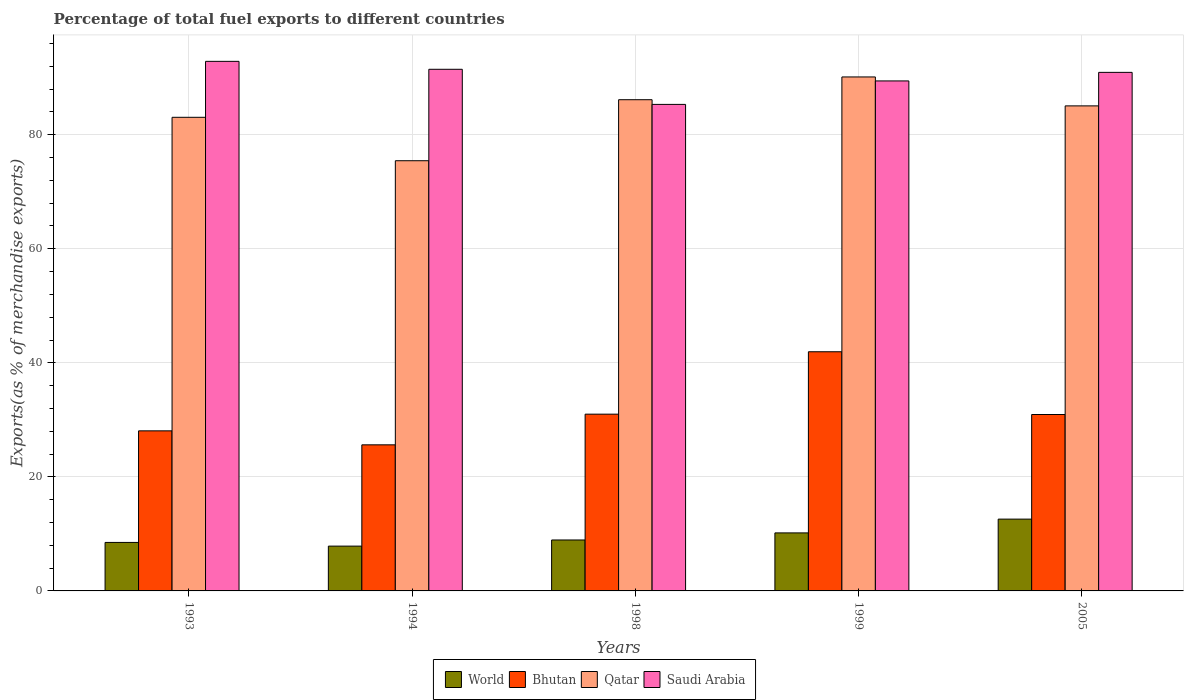How many different coloured bars are there?
Provide a succinct answer. 4. Are the number of bars per tick equal to the number of legend labels?
Give a very brief answer. Yes. Are the number of bars on each tick of the X-axis equal?
Your response must be concise. Yes. How many bars are there on the 3rd tick from the right?
Your answer should be very brief. 4. In how many cases, is the number of bars for a given year not equal to the number of legend labels?
Provide a short and direct response. 0. What is the percentage of exports to different countries in Bhutan in 1994?
Offer a terse response. 25.62. Across all years, what is the maximum percentage of exports to different countries in Bhutan?
Give a very brief answer. 41.94. Across all years, what is the minimum percentage of exports to different countries in World?
Provide a short and direct response. 7.86. What is the total percentage of exports to different countries in World in the graph?
Make the answer very short. 48.06. What is the difference between the percentage of exports to different countries in Qatar in 1994 and that in 1999?
Give a very brief answer. -14.69. What is the difference between the percentage of exports to different countries in World in 1993 and the percentage of exports to different countries in Saudi Arabia in 2005?
Your response must be concise. -82.43. What is the average percentage of exports to different countries in Bhutan per year?
Your answer should be very brief. 31.51. In the year 1998, what is the difference between the percentage of exports to different countries in Saudi Arabia and percentage of exports to different countries in World?
Give a very brief answer. 76.38. What is the ratio of the percentage of exports to different countries in World in 1993 to that in 2005?
Provide a short and direct response. 0.68. What is the difference between the highest and the second highest percentage of exports to different countries in World?
Keep it short and to the point. 2.42. What is the difference between the highest and the lowest percentage of exports to different countries in Saudi Arabia?
Offer a terse response. 7.55. In how many years, is the percentage of exports to different countries in Qatar greater than the average percentage of exports to different countries in Qatar taken over all years?
Ensure brevity in your answer.  3. Is the sum of the percentage of exports to different countries in Qatar in 1993 and 2005 greater than the maximum percentage of exports to different countries in Bhutan across all years?
Your answer should be very brief. Yes. Is it the case that in every year, the sum of the percentage of exports to different countries in Saudi Arabia and percentage of exports to different countries in Bhutan is greater than the sum of percentage of exports to different countries in World and percentage of exports to different countries in Qatar?
Offer a very short reply. Yes. What does the 1st bar from the left in 1999 represents?
Keep it short and to the point. World. What does the 3rd bar from the right in 1999 represents?
Your answer should be compact. Bhutan. What is the difference between two consecutive major ticks on the Y-axis?
Offer a very short reply. 20. Does the graph contain any zero values?
Your answer should be compact. No. Does the graph contain grids?
Your answer should be very brief. Yes. How many legend labels are there?
Your answer should be compact. 4. How are the legend labels stacked?
Provide a short and direct response. Horizontal. What is the title of the graph?
Make the answer very short. Percentage of total fuel exports to different countries. Does "Upper middle income" appear as one of the legend labels in the graph?
Provide a succinct answer. No. What is the label or title of the Y-axis?
Give a very brief answer. Exports(as % of merchandise exports). What is the Exports(as % of merchandise exports) in World in 1993?
Provide a succinct answer. 8.5. What is the Exports(as % of merchandise exports) in Bhutan in 1993?
Provide a short and direct response. 28.07. What is the Exports(as % of merchandise exports) in Qatar in 1993?
Your answer should be very brief. 83.06. What is the Exports(as % of merchandise exports) in Saudi Arabia in 1993?
Offer a terse response. 92.87. What is the Exports(as % of merchandise exports) in World in 1994?
Offer a terse response. 7.86. What is the Exports(as % of merchandise exports) of Bhutan in 1994?
Your answer should be very brief. 25.62. What is the Exports(as % of merchandise exports) of Qatar in 1994?
Your response must be concise. 75.44. What is the Exports(as % of merchandise exports) in Saudi Arabia in 1994?
Your response must be concise. 91.48. What is the Exports(as % of merchandise exports) of World in 1998?
Provide a succinct answer. 8.93. What is the Exports(as % of merchandise exports) in Bhutan in 1998?
Your answer should be very brief. 31. What is the Exports(as % of merchandise exports) in Qatar in 1998?
Provide a succinct answer. 86.14. What is the Exports(as % of merchandise exports) in Saudi Arabia in 1998?
Provide a short and direct response. 85.32. What is the Exports(as % of merchandise exports) of World in 1999?
Your response must be concise. 10.18. What is the Exports(as % of merchandise exports) in Bhutan in 1999?
Give a very brief answer. 41.94. What is the Exports(as % of merchandise exports) of Qatar in 1999?
Make the answer very short. 90.13. What is the Exports(as % of merchandise exports) in Saudi Arabia in 1999?
Provide a short and direct response. 89.44. What is the Exports(as % of merchandise exports) of World in 2005?
Your answer should be very brief. 12.59. What is the Exports(as % of merchandise exports) of Bhutan in 2005?
Make the answer very short. 30.94. What is the Exports(as % of merchandise exports) of Qatar in 2005?
Keep it short and to the point. 85.06. What is the Exports(as % of merchandise exports) of Saudi Arabia in 2005?
Ensure brevity in your answer.  90.94. Across all years, what is the maximum Exports(as % of merchandise exports) in World?
Ensure brevity in your answer.  12.59. Across all years, what is the maximum Exports(as % of merchandise exports) in Bhutan?
Your answer should be very brief. 41.94. Across all years, what is the maximum Exports(as % of merchandise exports) in Qatar?
Offer a very short reply. 90.13. Across all years, what is the maximum Exports(as % of merchandise exports) of Saudi Arabia?
Your answer should be very brief. 92.87. Across all years, what is the minimum Exports(as % of merchandise exports) of World?
Your answer should be very brief. 7.86. Across all years, what is the minimum Exports(as % of merchandise exports) in Bhutan?
Your response must be concise. 25.62. Across all years, what is the minimum Exports(as % of merchandise exports) of Qatar?
Offer a very short reply. 75.44. Across all years, what is the minimum Exports(as % of merchandise exports) of Saudi Arabia?
Provide a succinct answer. 85.32. What is the total Exports(as % of merchandise exports) in World in the graph?
Make the answer very short. 48.06. What is the total Exports(as % of merchandise exports) of Bhutan in the graph?
Your answer should be compact. 157.57. What is the total Exports(as % of merchandise exports) in Qatar in the graph?
Give a very brief answer. 419.83. What is the total Exports(as % of merchandise exports) of Saudi Arabia in the graph?
Provide a short and direct response. 450.03. What is the difference between the Exports(as % of merchandise exports) in World in 1993 and that in 1994?
Provide a succinct answer. 0.65. What is the difference between the Exports(as % of merchandise exports) of Bhutan in 1993 and that in 1994?
Your answer should be compact. 2.45. What is the difference between the Exports(as % of merchandise exports) of Qatar in 1993 and that in 1994?
Your response must be concise. 7.62. What is the difference between the Exports(as % of merchandise exports) in Saudi Arabia in 1993 and that in 1994?
Provide a short and direct response. 1.39. What is the difference between the Exports(as % of merchandise exports) of World in 1993 and that in 1998?
Ensure brevity in your answer.  -0.43. What is the difference between the Exports(as % of merchandise exports) in Bhutan in 1993 and that in 1998?
Provide a short and direct response. -2.93. What is the difference between the Exports(as % of merchandise exports) of Qatar in 1993 and that in 1998?
Your answer should be very brief. -3.09. What is the difference between the Exports(as % of merchandise exports) in Saudi Arabia in 1993 and that in 1998?
Keep it short and to the point. 7.55. What is the difference between the Exports(as % of merchandise exports) in World in 1993 and that in 1999?
Your answer should be very brief. -1.67. What is the difference between the Exports(as % of merchandise exports) in Bhutan in 1993 and that in 1999?
Your answer should be compact. -13.87. What is the difference between the Exports(as % of merchandise exports) of Qatar in 1993 and that in 1999?
Keep it short and to the point. -7.08. What is the difference between the Exports(as % of merchandise exports) of Saudi Arabia in 1993 and that in 1999?
Keep it short and to the point. 3.43. What is the difference between the Exports(as % of merchandise exports) in World in 1993 and that in 2005?
Offer a very short reply. -4.09. What is the difference between the Exports(as % of merchandise exports) of Bhutan in 1993 and that in 2005?
Your response must be concise. -2.87. What is the difference between the Exports(as % of merchandise exports) in Qatar in 1993 and that in 2005?
Offer a very short reply. -2. What is the difference between the Exports(as % of merchandise exports) of Saudi Arabia in 1993 and that in 2005?
Keep it short and to the point. 1.93. What is the difference between the Exports(as % of merchandise exports) of World in 1994 and that in 1998?
Offer a terse response. -1.08. What is the difference between the Exports(as % of merchandise exports) in Bhutan in 1994 and that in 1998?
Your response must be concise. -5.38. What is the difference between the Exports(as % of merchandise exports) in Qatar in 1994 and that in 1998?
Your response must be concise. -10.7. What is the difference between the Exports(as % of merchandise exports) in Saudi Arabia in 1994 and that in 1998?
Ensure brevity in your answer.  6.16. What is the difference between the Exports(as % of merchandise exports) in World in 1994 and that in 1999?
Your answer should be very brief. -2.32. What is the difference between the Exports(as % of merchandise exports) of Bhutan in 1994 and that in 1999?
Provide a short and direct response. -16.32. What is the difference between the Exports(as % of merchandise exports) of Qatar in 1994 and that in 1999?
Offer a terse response. -14.69. What is the difference between the Exports(as % of merchandise exports) in Saudi Arabia in 1994 and that in 1999?
Provide a succinct answer. 2.04. What is the difference between the Exports(as % of merchandise exports) in World in 1994 and that in 2005?
Make the answer very short. -4.74. What is the difference between the Exports(as % of merchandise exports) of Bhutan in 1994 and that in 2005?
Make the answer very short. -5.32. What is the difference between the Exports(as % of merchandise exports) in Qatar in 1994 and that in 2005?
Your answer should be compact. -9.62. What is the difference between the Exports(as % of merchandise exports) in Saudi Arabia in 1994 and that in 2005?
Your answer should be very brief. 0.54. What is the difference between the Exports(as % of merchandise exports) in World in 1998 and that in 1999?
Keep it short and to the point. -1.24. What is the difference between the Exports(as % of merchandise exports) in Bhutan in 1998 and that in 1999?
Your answer should be very brief. -10.94. What is the difference between the Exports(as % of merchandise exports) of Qatar in 1998 and that in 1999?
Make the answer very short. -3.99. What is the difference between the Exports(as % of merchandise exports) in Saudi Arabia in 1998 and that in 1999?
Offer a very short reply. -4.12. What is the difference between the Exports(as % of merchandise exports) of World in 1998 and that in 2005?
Your response must be concise. -3.66. What is the difference between the Exports(as % of merchandise exports) of Bhutan in 1998 and that in 2005?
Ensure brevity in your answer.  0.06. What is the difference between the Exports(as % of merchandise exports) in Qatar in 1998 and that in 2005?
Provide a succinct answer. 1.08. What is the difference between the Exports(as % of merchandise exports) in Saudi Arabia in 1998 and that in 2005?
Your response must be concise. -5.62. What is the difference between the Exports(as % of merchandise exports) in World in 1999 and that in 2005?
Provide a succinct answer. -2.42. What is the difference between the Exports(as % of merchandise exports) of Bhutan in 1999 and that in 2005?
Offer a very short reply. 11. What is the difference between the Exports(as % of merchandise exports) in Qatar in 1999 and that in 2005?
Ensure brevity in your answer.  5.07. What is the difference between the Exports(as % of merchandise exports) in Saudi Arabia in 1999 and that in 2005?
Keep it short and to the point. -1.5. What is the difference between the Exports(as % of merchandise exports) in World in 1993 and the Exports(as % of merchandise exports) in Bhutan in 1994?
Give a very brief answer. -17.12. What is the difference between the Exports(as % of merchandise exports) in World in 1993 and the Exports(as % of merchandise exports) in Qatar in 1994?
Make the answer very short. -66.94. What is the difference between the Exports(as % of merchandise exports) in World in 1993 and the Exports(as % of merchandise exports) in Saudi Arabia in 1994?
Keep it short and to the point. -82.97. What is the difference between the Exports(as % of merchandise exports) of Bhutan in 1993 and the Exports(as % of merchandise exports) of Qatar in 1994?
Your answer should be very brief. -47.37. What is the difference between the Exports(as % of merchandise exports) in Bhutan in 1993 and the Exports(as % of merchandise exports) in Saudi Arabia in 1994?
Your response must be concise. -63.41. What is the difference between the Exports(as % of merchandise exports) of Qatar in 1993 and the Exports(as % of merchandise exports) of Saudi Arabia in 1994?
Provide a short and direct response. -8.42. What is the difference between the Exports(as % of merchandise exports) of World in 1993 and the Exports(as % of merchandise exports) of Bhutan in 1998?
Offer a very short reply. -22.5. What is the difference between the Exports(as % of merchandise exports) in World in 1993 and the Exports(as % of merchandise exports) in Qatar in 1998?
Your response must be concise. -77.64. What is the difference between the Exports(as % of merchandise exports) of World in 1993 and the Exports(as % of merchandise exports) of Saudi Arabia in 1998?
Your response must be concise. -76.82. What is the difference between the Exports(as % of merchandise exports) of Bhutan in 1993 and the Exports(as % of merchandise exports) of Qatar in 1998?
Offer a very short reply. -58.07. What is the difference between the Exports(as % of merchandise exports) of Bhutan in 1993 and the Exports(as % of merchandise exports) of Saudi Arabia in 1998?
Provide a succinct answer. -57.25. What is the difference between the Exports(as % of merchandise exports) of Qatar in 1993 and the Exports(as % of merchandise exports) of Saudi Arabia in 1998?
Provide a succinct answer. -2.26. What is the difference between the Exports(as % of merchandise exports) of World in 1993 and the Exports(as % of merchandise exports) of Bhutan in 1999?
Your answer should be compact. -33.44. What is the difference between the Exports(as % of merchandise exports) of World in 1993 and the Exports(as % of merchandise exports) of Qatar in 1999?
Your response must be concise. -81.63. What is the difference between the Exports(as % of merchandise exports) of World in 1993 and the Exports(as % of merchandise exports) of Saudi Arabia in 1999?
Your answer should be very brief. -80.93. What is the difference between the Exports(as % of merchandise exports) in Bhutan in 1993 and the Exports(as % of merchandise exports) in Qatar in 1999?
Offer a very short reply. -62.06. What is the difference between the Exports(as % of merchandise exports) in Bhutan in 1993 and the Exports(as % of merchandise exports) in Saudi Arabia in 1999?
Your answer should be very brief. -61.36. What is the difference between the Exports(as % of merchandise exports) of Qatar in 1993 and the Exports(as % of merchandise exports) of Saudi Arabia in 1999?
Ensure brevity in your answer.  -6.38. What is the difference between the Exports(as % of merchandise exports) in World in 1993 and the Exports(as % of merchandise exports) in Bhutan in 2005?
Your answer should be very brief. -22.43. What is the difference between the Exports(as % of merchandise exports) in World in 1993 and the Exports(as % of merchandise exports) in Qatar in 2005?
Keep it short and to the point. -76.56. What is the difference between the Exports(as % of merchandise exports) in World in 1993 and the Exports(as % of merchandise exports) in Saudi Arabia in 2005?
Ensure brevity in your answer.  -82.43. What is the difference between the Exports(as % of merchandise exports) of Bhutan in 1993 and the Exports(as % of merchandise exports) of Qatar in 2005?
Make the answer very short. -56.99. What is the difference between the Exports(as % of merchandise exports) of Bhutan in 1993 and the Exports(as % of merchandise exports) of Saudi Arabia in 2005?
Your answer should be compact. -62.86. What is the difference between the Exports(as % of merchandise exports) in Qatar in 1993 and the Exports(as % of merchandise exports) in Saudi Arabia in 2005?
Your answer should be compact. -7.88. What is the difference between the Exports(as % of merchandise exports) in World in 1994 and the Exports(as % of merchandise exports) in Bhutan in 1998?
Offer a very short reply. -23.14. What is the difference between the Exports(as % of merchandise exports) of World in 1994 and the Exports(as % of merchandise exports) of Qatar in 1998?
Make the answer very short. -78.28. What is the difference between the Exports(as % of merchandise exports) in World in 1994 and the Exports(as % of merchandise exports) in Saudi Arabia in 1998?
Your response must be concise. -77.46. What is the difference between the Exports(as % of merchandise exports) of Bhutan in 1994 and the Exports(as % of merchandise exports) of Qatar in 1998?
Offer a very short reply. -60.52. What is the difference between the Exports(as % of merchandise exports) in Bhutan in 1994 and the Exports(as % of merchandise exports) in Saudi Arabia in 1998?
Give a very brief answer. -59.7. What is the difference between the Exports(as % of merchandise exports) in Qatar in 1994 and the Exports(as % of merchandise exports) in Saudi Arabia in 1998?
Offer a terse response. -9.88. What is the difference between the Exports(as % of merchandise exports) in World in 1994 and the Exports(as % of merchandise exports) in Bhutan in 1999?
Give a very brief answer. -34.08. What is the difference between the Exports(as % of merchandise exports) in World in 1994 and the Exports(as % of merchandise exports) in Qatar in 1999?
Offer a very short reply. -82.28. What is the difference between the Exports(as % of merchandise exports) of World in 1994 and the Exports(as % of merchandise exports) of Saudi Arabia in 1999?
Offer a terse response. -81.58. What is the difference between the Exports(as % of merchandise exports) in Bhutan in 1994 and the Exports(as % of merchandise exports) in Qatar in 1999?
Ensure brevity in your answer.  -64.52. What is the difference between the Exports(as % of merchandise exports) in Bhutan in 1994 and the Exports(as % of merchandise exports) in Saudi Arabia in 1999?
Offer a terse response. -63.82. What is the difference between the Exports(as % of merchandise exports) of Qatar in 1994 and the Exports(as % of merchandise exports) of Saudi Arabia in 1999?
Offer a terse response. -14. What is the difference between the Exports(as % of merchandise exports) in World in 1994 and the Exports(as % of merchandise exports) in Bhutan in 2005?
Ensure brevity in your answer.  -23.08. What is the difference between the Exports(as % of merchandise exports) of World in 1994 and the Exports(as % of merchandise exports) of Qatar in 2005?
Give a very brief answer. -77.2. What is the difference between the Exports(as % of merchandise exports) of World in 1994 and the Exports(as % of merchandise exports) of Saudi Arabia in 2005?
Offer a very short reply. -83.08. What is the difference between the Exports(as % of merchandise exports) of Bhutan in 1994 and the Exports(as % of merchandise exports) of Qatar in 2005?
Provide a short and direct response. -59.44. What is the difference between the Exports(as % of merchandise exports) in Bhutan in 1994 and the Exports(as % of merchandise exports) in Saudi Arabia in 2005?
Provide a succinct answer. -65.32. What is the difference between the Exports(as % of merchandise exports) in Qatar in 1994 and the Exports(as % of merchandise exports) in Saudi Arabia in 2005?
Keep it short and to the point. -15.5. What is the difference between the Exports(as % of merchandise exports) in World in 1998 and the Exports(as % of merchandise exports) in Bhutan in 1999?
Your response must be concise. -33.01. What is the difference between the Exports(as % of merchandise exports) of World in 1998 and the Exports(as % of merchandise exports) of Qatar in 1999?
Your answer should be very brief. -81.2. What is the difference between the Exports(as % of merchandise exports) of World in 1998 and the Exports(as % of merchandise exports) of Saudi Arabia in 1999?
Provide a succinct answer. -80.5. What is the difference between the Exports(as % of merchandise exports) in Bhutan in 1998 and the Exports(as % of merchandise exports) in Qatar in 1999?
Your answer should be very brief. -59.14. What is the difference between the Exports(as % of merchandise exports) in Bhutan in 1998 and the Exports(as % of merchandise exports) in Saudi Arabia in 1999?
Offer a very short reply. -58.44. What is the difference between the Exports(as % of merchandise exports) of Qatar in 1998 and the Exports(as % of merchandise exports) of Saudi Arabia in 1999?
Your answer should be very brief. -3.29. What is the difference between the Exports(as % of merchandise exports) of World in 1998 and the Exports(as % of merchandise exports) of Bhutan in 2005?
Keep it short and to the point. -22. What is the difference between the Exports(as % of merchandise exports) in World in 1998 and the Exports(as % of merchandise exports) in Qatar in 2005?
Ensure brevity in your answer.  -76.13. What is the difference between the Exports(as % of merchandise exports) in World in 1998 and the Exports(as % of merchandise exports) in Saudi Arabia in 2005?
Give a very brief answer. -82. What is the difference between the Exports(as % of merchandise exports) of Bhutan in 1998 and the Exports(as % of merchandise exports) of Qatar in 2005?
Make the answer very short. -54.06. What is the difference between the Exports(as % of merchandise exports) in Bhutan in 1998 and the Exports(as % of merchandise exports) in Saudi Arabia in 2005?
Keep it short and to the point. -59.94. What is the difference between the Exports(as % of merchandise exports) in Qatar in 1998 and the Exports(as % of merchandise exports) in Saudi Arabia in 2005?
Offer a terse response. -4.79. What is the difference between the Exports(as % of merchandise exports) in World in 1999 and the Exports(as % of merchandise exports) in Bhutan in 2005?
Make the answer very short. -20.76. What is the difference between the Exports(as % of merchandise exports) of World in 1999 and the Exports(as % of merchandise exports) of Qatar in 2005?
Keep it short and to the point. -74.88. What is the difference between the Exports(as % of merchandise exports) of World in 1999 and the Exports(as % of merchandise exports) of Saudi Arabia in 2005?
Your answer should be compact. -80.76. What is the difference between the Exports(as % of merchandise exports) in Bhutan in 1999 and the Exports(as % of merchandise exports) in Qatar in 2005?
Your answer should be compact. -43.12. What is the difference between the Exports(as % of merchandise exports) of Bhutan in 1999 and the Exports(as % of merchandise exports) of Saudi Arabia in 2005?
Your answer should be very brief. -48.99. What is the difference between the Exports(as % of merchandise exports) in Qatar in 1999 and the Exports(as % of merchandise exports) in Saudi Arabia in 2005?
Provide a succinct answer. -0.8. What is the average Exports(as % of merchandise exports) of World per year?
Provide a short and direct response. 9.61. What is the average Exports(as % of merchandise exports) of Bhutan per year?
Keep it short and to the point. 31.51. What is the average Exports(as % of merchandise exports) in Qatar per year?
Offer a terse response. 83.97. What is the average Exports(as % of merchandise exports) in Saudi Arabia per year?
Provide a short and direct response. 90.01. In the year 1993, what is the difference between the Exports(as % of merchandise exports) of World and Exports(as % of merchandise exports) of Bhutan?
Offer a terse response. -19.57. In the year 1993, what is the difference between the Exports(as % of merchandise exports) of World and Exports(as % of merchandise exports) of Qatar?
Give a very brief answer. -74.55. In the year 1993, what is the difference between the Exports(as % of merchandise exports) of World and Exports(as % of merchandise exports) of Saudi Arabia?
Offer a terse response. -84.37. In the year 1993, what is the difference between the Exports(as % of merchandise exports) in Bhutan and Exports(as % of merchandise exports) in Qatar?
Your answer should be compact. -54.98. In the year 1993, what is the difference between the Exports(as % of merchandise exports) of Bhutan and Exports(as % of merchandise exports) of Saudi Arabia?
Make the answer very short. -64.8. In the year 1993, what is the difference between the Exports(as % of merchandise exports) in Qatar and Exports(as % of merchandise exports) in Saudi Arabia?
Provide a short and direct response. -9.81. In the year 1994, what is the difference between the Exports(as % of merchandise exports) in World and Exports(as % of merchandise exports) in Bhutan?
Offer a very short reply. -17.76. In the year 1994, what is the difference between the Exports(as % of merchandise exports) in World and Exports(as % of merchandise exports) in Qatar?
Your response must be concise. -67.58. In the year 1994, what is the difference between the Exports(as % of merchandise exports) in World and Exports(as % of merchandise exports) in Saudi Arabia?
Your answer should be compact. -83.62. In the year 1994, what is the difference between the Exports(as % of merchandise exports) in Bhutan and Exports(as % of merchandise exports) in Qatar?
Provide a succinct answer. -49.82. In the year 1994, what is the difference between the Exports(as % of merchandise exports) in Bhutan and Exports(as % of merchandise exports) in Saudi Arabia?
Your answer should be compact. -65.86. In the year 1994, what is the difference between the Exports(as % of merchandise exports) in Qatar and Exports(as % of merchandise exports) in Saudi Arabia?
Make the answer very short. -16.04. In the year 1998, what is the difference between the Exports(as % of merchandise exports) of World and Exports(as % of merchandise exports) of Bhutan?
Your answer should be compact. -22.06. In the year 1998, what is the difference between the Exports(as % of merchandise exports) of World and Exports(as % of merchandise exports) of Qatar?
Your answer should be very brief. -77.21. In the year 1998, what is the difference between the Exports(as % of merchandise exports) in World and Exports(as % of merchandise exports) in Saudi Arabia?
Offer a terse response. -76.38. In the year 1998, what is the difference between the Exports(as % of merchandise exports) in Bhutan and Exports(as % of merchandise exports) in Qatar?
Ensure brevity in your answer.  -55.14. In the year 1998, what is the difference between the Exports(as % of merchandise exports) of Bhutan and Exports(as % of merchandise exports) of Saudi Arabia?
Your answer should be compact. -54.32. In the year 1998, what is the difference between the Exports(as % of merchandise exports) in Qatar and Exports(as % of merchandise exports) in Saudi Arabia?
Offer a very short reply. 0.82. In the year 1999, what is the difference between the Exports(as % of merchandise exports) of World and Exports(as % of merchandise exports) of Bhutan?
Offer a terse response. -31.77. In the year 1999, what is the difference between the Exports(as % of merchandise exports) in World and Exports(as % of merchandise exports) in Qatar?
Your answer should be compact. -79.96. In the year 1999, what is the difference between the Exports(as % of merchandise exports) in World and Exports(as % of merchandise exports) in Saudi Arabia?
Offer a terse response. -79.26. In the year 1999, what is the difference between the Exports(as % of merchandise exports) in Bhutan and Exports(as % of merchandise exports) in Qatar?
Provide a succinct answer. -48.19. In the year 1999, what is the difference between the Exports(as % of merchandise exports) of Bhutan and Exports(as % of merchandise exports) of Saudi Arabia?
Your answer should be very brief. -47.49. In the year 1999, what is the difference between the Exports(as % of merchandise exports) in Qatar and Exports(as % of merchandise exports) in Saudi Arabia?
Your response must be concise. 0.7. In the year 2005, what is the difference between the Exports(as % of merchandise exports) in World and Exports(as % of merchandise exports) in Bhutan?
Ensure brevity in your answer.  -18.35. In the year 2005, what is the difference between the Exports(as % of merchandise exports) of World and Exports(as % of merchandise exports) of Qatar?
Your response must be concise. -72.47. In the year 2005, what is the difference between the Exports(as % of merchandise exports) of World and Exports(as % of merchandise exports) of Saudi Arabia?
Provide a succinct answer. -78.34. In the year 2005, what is the difference between the Exports(as % of merchandise exports) in Bhutan and Exports(as % of merchandise exports) in Qatar?
Your answer should be compact. -54.12. In the year 2005, what is the difference between the Exports(as % of merchandise exports) of Bhutan and Exports(as % of merchandise exports) of Saudi Arabia?
Make the answer very short. -60. In the year 2005, what is the difference between the Exports(as % of merchandise exports) in Qatar and Exports(as % of merchandise exports) in Saudi Arabia?
Give a very brief answer. -5.88. What is the ratio of the Exports(as % of merchandise exports) of World in 1993 to that in 1994?
Give a very brief answer. 1.08. What is the ratio of the Exports(as % of merchandise exports) of Bhutan in 1993 to that in 1994?
Make the answer very short. 1.1. What is the ratio of the Exports(as % of merchandise exports) of Qatar in 1993 to that in 1994?
Provide a succinct answer. 1.1. What is the ratio of the Exports(as % of merchandise exports) of Saudi Arabia in 1993 to that in 1994?
Offer a terse response. 1.02. What is the ratio of the Exports(as % of merchandise exports) in World in 1993 to that in 1998?
Offer a very short reply. 0.95. What is the ratio of the Exports(as % of merchandise exports) in Bhutan in 1993 to that in 1998?
Your response must be concise. 0.91. What is the ratio of the Exports(as % of merchandise exports) of Qatar in 1993 to that in 1998?
Offer a very short reply. 0.96. What is the ratio of the Exports(as % of merchandise exports) of Saudi Arabia in 1993 to that in 1998?
Make the answer very short. 1.09. What is the ratio of the Exports(as % of merchandise exports) in World in 1993 to that in 1999?
Make the answer very short. 0.84. What is the ratio of the Exports(as % of merchandise exports) in Bhutan in 1993 to that in 1999?
Your answer should be very brief. 0.67. What is the ratio of the Exports(as % of merchandise exports) in Qatar in 1993 to that in 1999?
Offer a very short reply. 0.92. What is the ratio of the Exports(as % of merchandise exports) of Saudi Arabia in 1993 to that in 1999?
Offer a very short reply. 1.04. What is the ratio of the Exports(as % of merchandise exports) in World in 1993 to that in 2005?
Offer a terse response. 0.68. What is the ratio of the Exports(as % of merchandise exports) of Bhutan in 1993 to that in 2005?
Give a very brief answer. 0.91. What is the ratio of the Exports(as % of merchandise exports) in Qatar in 1993 to that in 2005?
Provide a short and direct response. 0.98. What is the ratio of the Exports(as % of merchandise exports) of Saudi Arabia in 1993 to that in 2005?
Offer a terse response. 1.02. What is the ratio of the Exports(as % of merchandise exports) in World in 1994 to that in 1998?
Offer a very short reply. 0.88. What is the ratio of the Exports(as % of merchandise exports) of Bhutan in 1994 to that in 1998?
Provide a succinct answer. 0.83. What is the ratio of the Exports(as % of merchandise exports) of Qatar in 1994 to that in 1998?
Your answer should be compact. 0.88. What is the ratio of the Exports(as % of merchandise exports) of Saudi Arabia in 1994 to that in 1998?
Provide a succinct answer. 1.07. What is the ratio of the Exports(as % of merchandise exports) in World in 1994 to that in 1999?
Give a very brief answer. 0.77. What is the ratio of the Exports(as % of merchandise exports) in Bhutan in 1994 to that in 1999?
Keep it short and to the point. 0.61. What is the ratio of the Exports(as % of merchandise exports) of Qatar in 1994 to that in 1999?
Provide a short and direct response. 0.84. What is the ratio of the Exports(as % of merchandise exports) in Saudi Arabia in 1994 to that in 1999?
Make the answer very short. 1.02. What is the ratio of the Exports(as % of merchandise exports) of World in 1994 to that in 2005?
Give a very brief answer. 0.62. What is the ratio of the Exports(as % of merchandise exports) of Bhutan in 1994 to that in 2005?
Give a very brief answer. 0.83. What is the ratio of the Exports(as % of merchandise exports) in Qatar in 1994 to that in 2005?
Your answer should be compact. 0.89. What is the ratio of the Exports(as % of merchandise exports) in Saudi Arabia in 1994 to that in 2005?
Offer a terse response. 1.01. What is the ratio of the Exports(as % of merchandise exports) in World in 1998 to that in 1999?
Your answer should be compact. 0.88. What is the ratio of the Exports(as % of merchandise exports) in Bhutan in 1998 to that in 1999?
Provide a succinct answer. 0.74. What is the ratio of the Exports(as % of merchandise exports) in Qatar in 1998 to that in 1999?
Provide a short and direct response. 0.96. What is the ratio of the Exports(as % of merchandise exports) in Saudi Arabia in 1998 to that in 1999?
Your response must be concise. 0.95. What is the ratio of the Exports(as % of merchandise exports) in World in 1998 to that in 2005?
Offer a terse response. 0.71. What is the ratio of the Exports(as % of merchandise exports) of Qatar in 1998 to that in 2005?
Make the answer very short. 1.01. What is the ratio of the Exports(as % of merchandise exports) in Saudi Arabia in 1998 to that in 2005?
Your answer should be very brief. 0.94. What is the ratio of the Exports(as % of merchandise exports) in World in 1999 to that in 2005?
Keep it short and to the point. 0.81. What is the ratio of the Exports(as % of merchandise exports) in Bhutan in 1999 to that in 2005?
Provide a short and direct response. 1.36. What is the ratio of the Exports(as % of merchandise exports) in Qatar in 1999 to that in 2005?
Your answer should be very brief. 1.06. What is the ratio of the Exports(as % of merchandise exports) of Saudi Arabia in 1999 to that in 2005?
Offer a very short reply. 0.98. What is the difference between the highest and the second highest Exports(as % of merchandise exports) of World?
Offer a terse response. 2.42. What is the difference between the highest and the second highest Exports(as % of merchandise exports) of Bhutan?
Provide a short and direct response. 10.94. What is the difference between the highest and the second highest Exports(as % of merchandise exports) of Qatar?
Provide a succinct answer. 3.99. What is the difference between the highest and the second highest Exports(as % of merchandise exports) of Saudi Arabia?
Provide a succinct answer. 1.39. What is the difference between the highest and the lowest Exports(as % of merchandise exports) of World?
Make the answer very short. 4.74. What is the difference between the highest and the lowest Exports(as % of merchandise exports) in Bhutan?
Your answer should be compact. 16.32. What is the difference between the highest and the lowest Exports(as % of merchandise exports) of Qatar?
Provide a succinct answer. 14.69. What is the difference between the highest and the lowest Exports(as % of merchandise exports) of Saudi Arabia?
Your response must be concise. 7.55. 